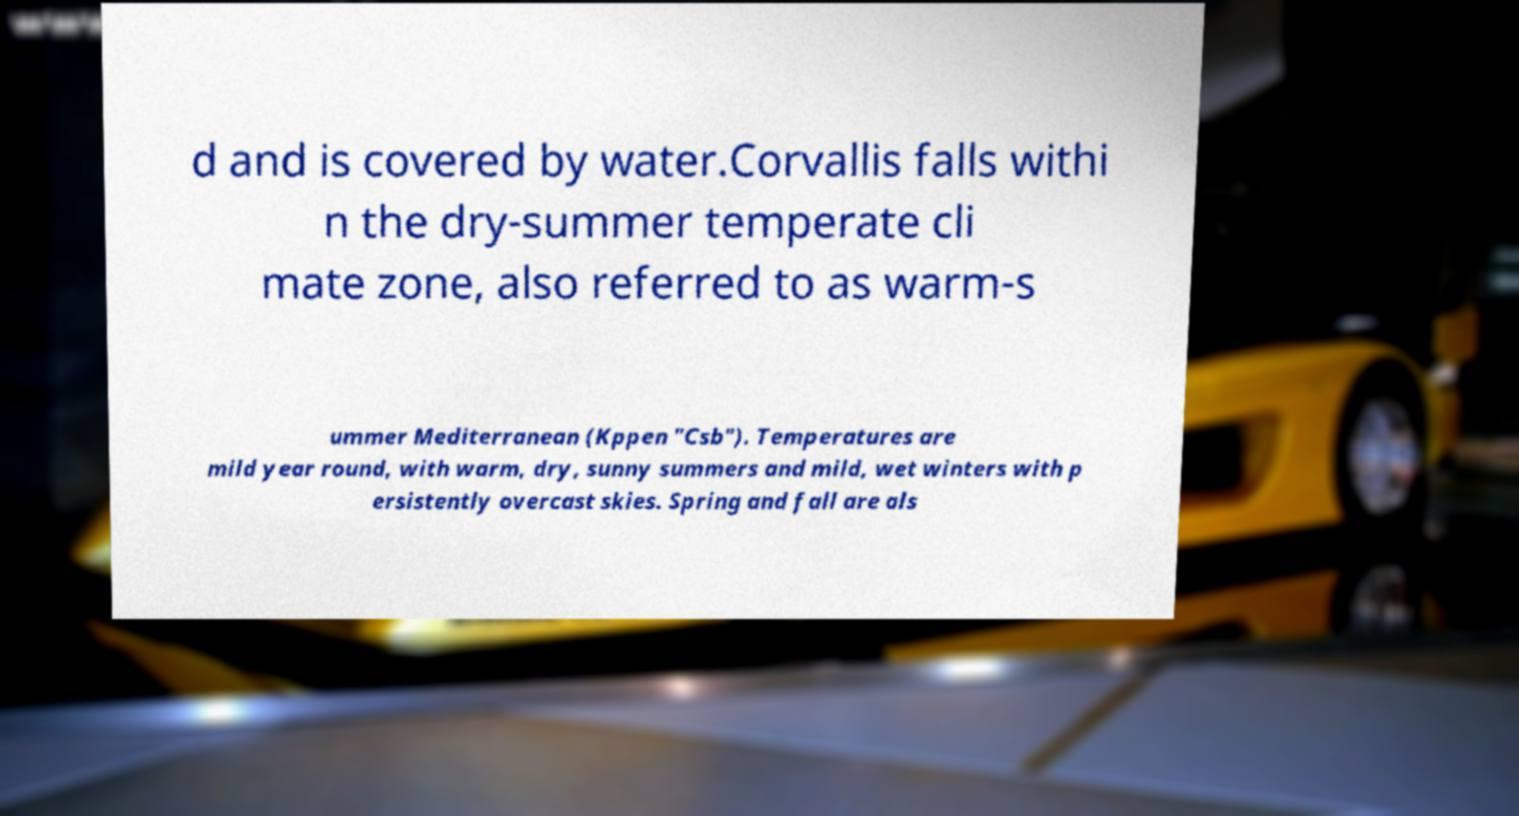Can you accurately transcribe the text from the provided image for me? d and is covered by water.Corvallis falls withi n the dry-summer temperate cli mate zone, also referred to as warm-s ummer Mediterranean (Kppen "Csb"). Temperatures are mild year round, with warm, dry, sunny summers and mild, wet winters with p ersistently overcast skies. Spring and fall are als 